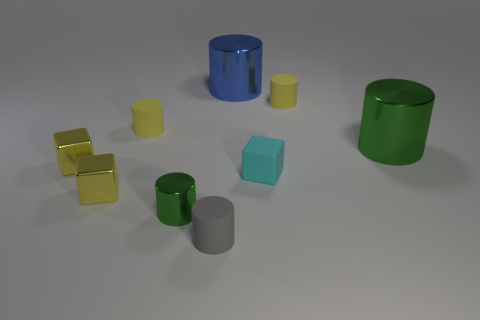What number of things are yellow things left of the cyan thing or large metal blocks?
Make the answer very short. 3. Are there an equal number of big green cylinders that are behind the big blue metal thing and big blue things?
Offer a terse response. No. Is the tiny metal cylinder the same color as the tiny rubber cube?
Offer a very short reply. No. What is the color of the cylinder that is both in front of the matte cube and to the left of the small gray matte cylinder?
Your answer should be compact. Green. What number of cylinders are either cyan objects or tiny rubber objects?
Offer a very short reply. 3. Is the number of small gray cylinders that are to the right of the large green shiny cylinder less than the number of tiny gray rubber balls?
Provide a succinct answer. No. The large thing that is made of the same material as the large green cylinder is what shape?
Your answer should be very brief. Cylinder. How many small things are the same color as the tiny rubber cube?
Provide a succinct answer. 0. How many things are big gray matte balls or gray rubber objects?
Offer a terse response. 1. What is the green cylinder to the right of the green cylinder on the left side of the big green object made of?
Provide a short and direct response. Metal. 